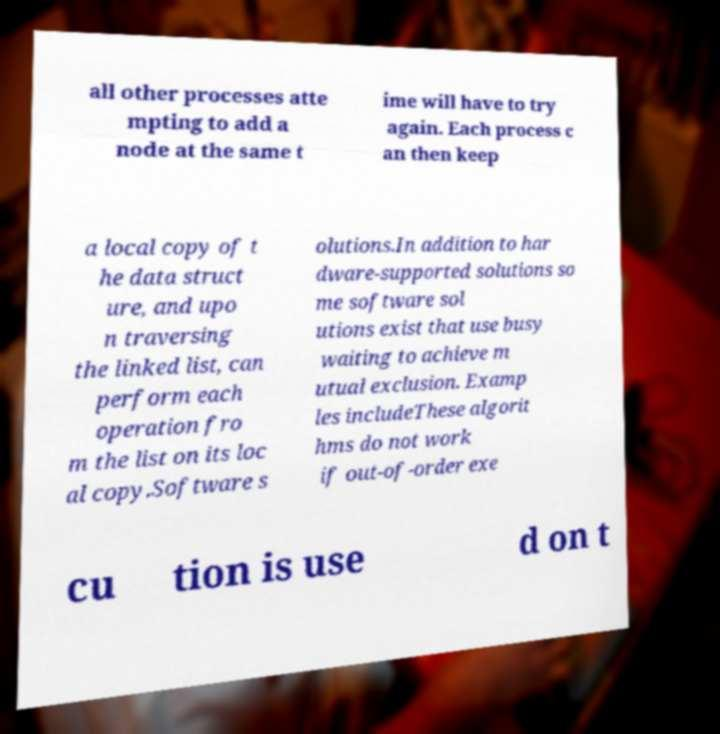Please read and relay the text visible in this image. What does it say? all other processes atte mpting to add a node at the same t ime will have to try again. Each process c an then keep a local copy of t he data struct ure, and upo n traversing the linked list, can perform each operation fro m the list on its loc al copy.Software s olutions.In addition to har dware-supported solutions so me software sol utions exist that use busy waiting to achieve m utual exclusion. Examp les includeThese algorit hms do not work if out-of-order exe cu tion is use d on t 